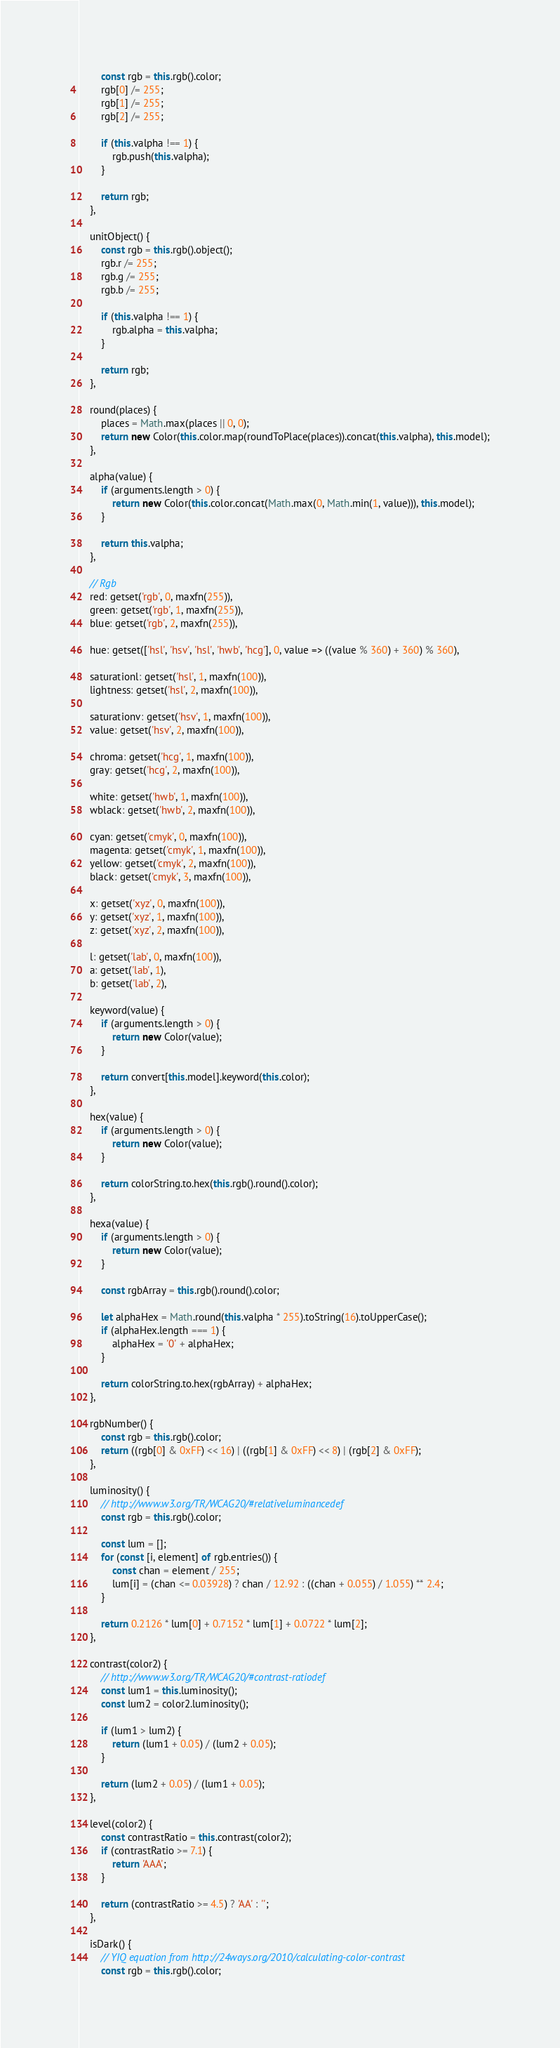<code> <loc_0><loc_0><loc_500><loc_500><_JavaScript_>		const rgb = this.rgb().color;
		rgb[0] /= 255;
		rgb[1] /= 255;
		rgb[2] /= 255;

		if (this.valpha !== 1) {
			rgb.push(this.valpha);
		}

		return rgb;
	},

	unitObject() {
		const rgb = this.rgb().object();
		rgb.r /= 255;
		rgb.g /= 255;
		rgb.b /= 255;

		if (this.valpha !== 1) {
			rgb.alpha = this.valpha;
		}

		return rgb;
	},

	round(places) {
		places = Math.max(places || 0, 0);
		return new Color(this.color.map(roundToPlace(places)).concat(this.valpha), this.model);
	},

	alpha(value) {
		if (arguments.length > 0) {
			return new Color(this.color.concat(Math.max(0, Math.min(1, value))), this.model);
		}

		return this.valpha;
	},

	// Rgb
	red: getset('rgb', 0, maxfn(255)),
	green: getset('rgb', 1, maxfn(255)),
	blue: getset('rgb', 2, maxfn(255)),

	hue: getset(['hsl', 'hsv', 'hsl', 'hwb', 'hcg'], 0, value => ((value % 360) + 360) % 360),

	saturationl: getset('hsl', 1, maxfn(100)),
	lightness: getset('hsl', 2, maxfn(100)),

	saturationv: getset('hsv', 1, maxfn(100)),
	value: getset('hsv', 2, maxfn(100)),

	chroma: getset('hcg', 1, maxfn(100)),
	gray: getset('hcg', 2, maxfn(100)),

	white: getset('hwb', 1, maxfn(100)),
	wblack: getset('hwb', 2, maxfn(100)),

	cyan: getset('cmyk', 0, maxfn(100)),
	magenta: getset('cmyk', 1, maxfn(100)),
	yellow: getset('cmyk', 2, maxfn(100)),
	black: getset('cmyk', 3, maxfn(100)),

	x: getset('xyz', 0, maxfn(100)),
	y: getset('xyz', 1, maxfn(100)),
	z: getset('xyz', 2, maxfn(100)),

	l: getset('lab', 0, maxfn(100)),
	a: getset('lab', 1),
	b: getset('lab', 2),

	keyword(value) {
		if (arguments.length > 0) {
			return new Color(value);
		}

		return convert[this.model].keyword(this.color);
	},

	hex(value) {
		if (arguments.length > 0) {
			return new Color(value);
		}

		return colorString.to.hex(this.rgb().round().color);
	},

	hexa(value) {
		if (arguments.length > 0) {
			return new Color(value);
		}

		const rgbArray = this.rgb().round().color;

		let alphaHex = Math.round(this.valpha * 255).toString(16).toUpperCase();
		if (alphaHex.length === 1) {
			alphaHex = '0' + alphaHex;
		}

		return colorString.to.hex(rgbArray) + alphaHex;
	},

	rgbNumber() {
		const rgb = this.rgb().color;
		return ((rgb[0] & 0xFF) << 16) | ((rgb[1] & 0xFF) << 8) | (rgb[2] & 0xFF);
	},

	luminosity() {
		// http://www.w3.org/TR/WCAG20/#relativeluminancedef
		const rgb = this.rgb().color;

		const lum = [];
		for (const [i, element] of rgb.entries()) {
			const chan = element / 255;
			lum[i] = (chan <= 0.03928) ? chan / 12.92 : ((chan + 0.055) / 1.055) ** 2.4;
		}

		return 0.2126 * lum[0] + 0.7152 * lum[1] + 0.0722 * lum[2];
	},

	contrast(color2) {
		// http://www.w3.org/TR/WCAG20/#contrast-ratiodef
		const lum1 = this.luminosity();
		const lum2 = color2.luminosity();

		if (lum1 > lum2) {
			return (lum1 + 0.05) / (lum2 + 0.05);
		}

		return (lum2 + 0.05) / (lum1 + 0.05);
	},

	level(color2) {
		const contrastRatio = this.contrast(color2);
		if (contrastRatio >= 7.1) {
			return 'AAA';
		}

		return (contrastRatio >= 4.5) ? 'AA' : '';
	},

	isDark() {
		// YIQ equation from http://24ways.org/2010/calculating-color-contrast
		const rgb = this.rgb().color;</code> 